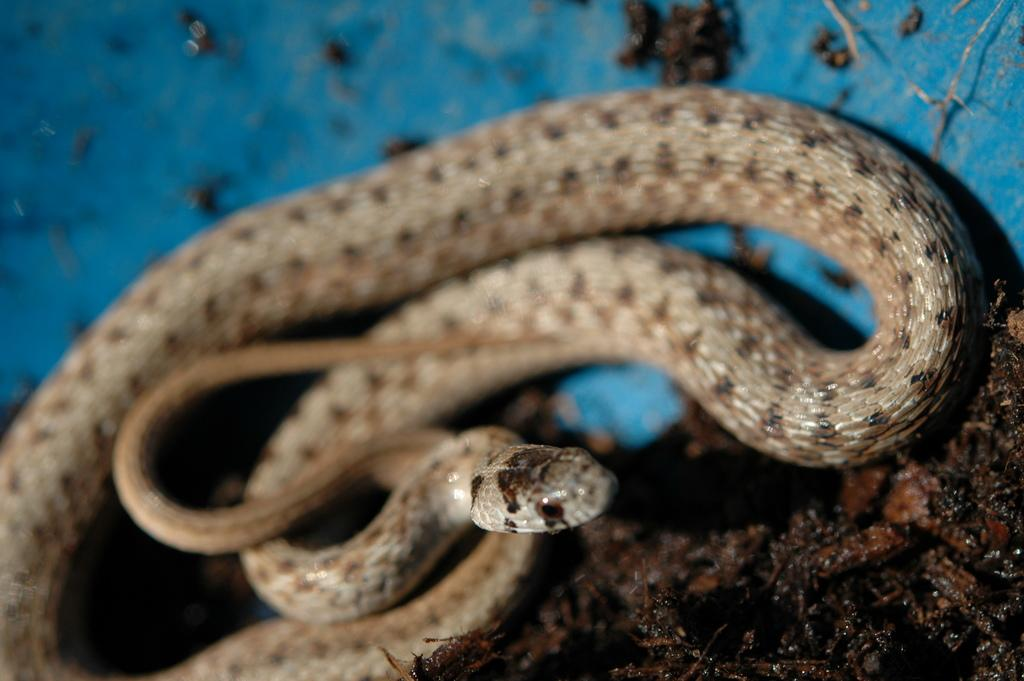What animal is present in the image? There is a snake in the image. What color is the background of the image? The background of the image is blue. Where is the pin located in the image? There is no pin present in the image. What action is the snake performing in the image? The image does not show the snake performing any specific action; it is simply depicted as being in the scene. 